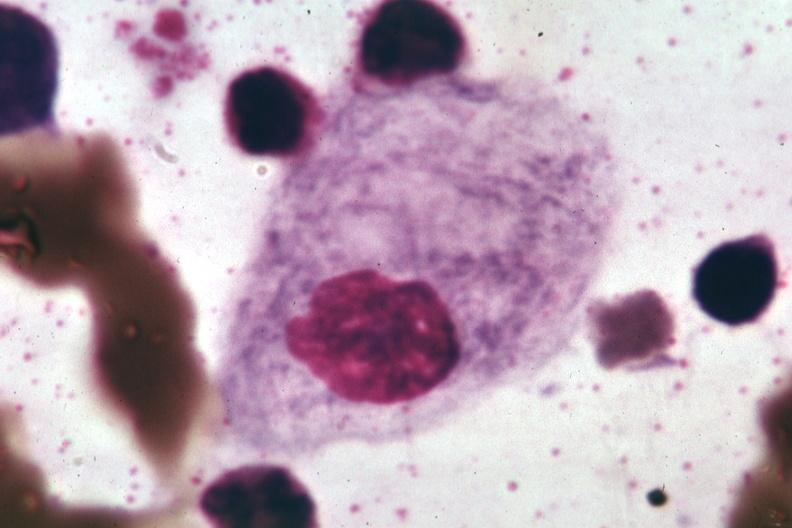s gaucher cell present?
Answer the question using a single word or phrase. Yes 